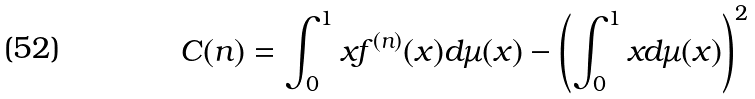Convert formula to latex. <formula><loc_0><loc_0><loc_500><loc_500>C ( n ) = \int _ { 0 } ^ { 1 } x f ^ { ( n ) } ( x ) d \mu ( x ) - \left ( \int _ { 0 } ^ { 1 } x d \mu ( x ) \right ) ^ { 2 }</formula> 